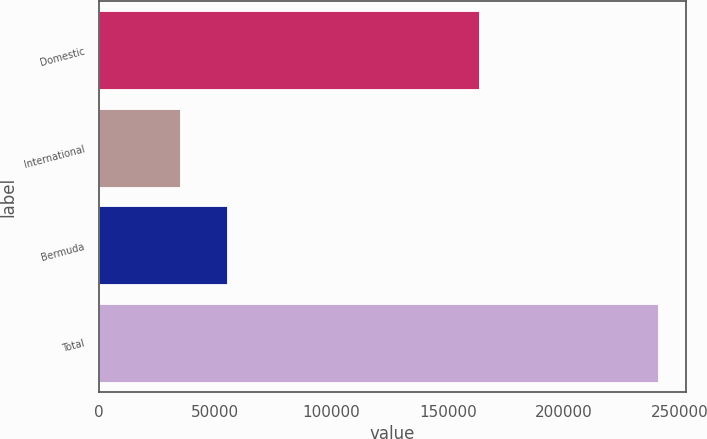Convert chart. <chart><loc_0><loc_0><loc_500><loc_500><bar_chart><fcel>Domestic<fcel>International<fcel>Bermuda<fcel>Total<nl><fcel>163584<fcel>34598<fcel>55178.2<fcel>240400<nl></chart> 